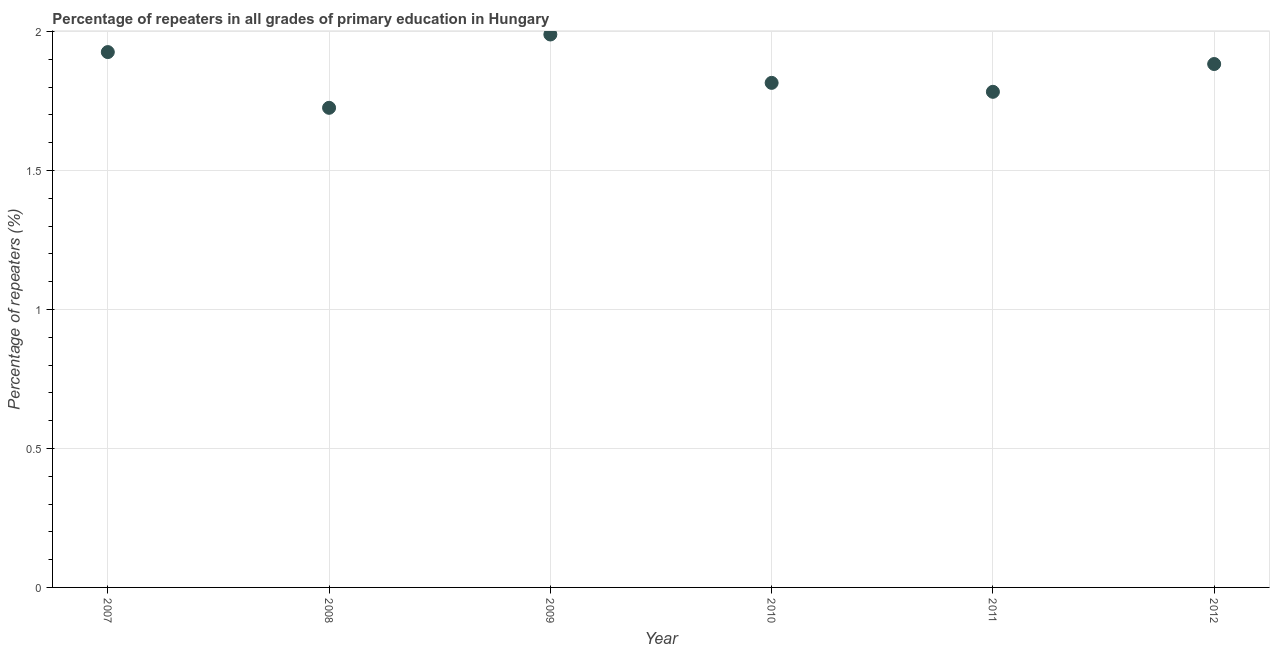What is the percentage of repeaters in primary education in 2010?
Keep it short and to the point. 1.82. Across all years, what is the maximum percentage of repeaters in primary education?
Give a very brief answer. 1.99. Across all years, what is the minimum percentage of repeaters in primary education?
Your response must be concise. 1.73. In which year was the percentage of repeaters in primary education maximum?
Keep it short and to the point. 2009. What is the sum of the percentage of repeaters in primary education?
Your response must be concise. 11.12. What is the difference between the percentage of repeaters in primary education in 2010 and 2011?
Provide a succinct answer. 0.03. What is the average percentage of repeaters in primary education per year?
Give a very brief answer. 1.85. What is the median percentage of repeaters in primary education?
Provide a short and direct response. 1.85. In how many years, is the percentage of repeaters in primary education greater than 1.8 %?
Make the answer very short. 4. What is the ratio of the percentage of repeaters in primary education in 2010 to that in 2011?
Your answer should be very brief. 1.02. Is the difference between the percentage of repeaters in primary education in 2008 and 2012 greater than the difference between any two years?
Ensure brevity in your answer.  No. What is the difference between the highest and the second highest percentage of repeaters in primary education?
Keep it short and to the point. 0.06. Is the sum of the percentage of repeaters in primary education in 2008 and 2012 greater than the maximum percentage of repeaters in primary education across all years?
Provide a succinct answer. Yes. What is the difference between the highest and the lowest percentage of repeaters in primary education?
Make the answer very short. 0.26. In how many years, is the percentage of repeaters in primary education greater than the average percentage of repeaters in primary education taken over all years?
Provide a short and direct response. 3. How many dotlines are there?
Keep it short and to the point. 1. How many years are there in the graph?
Your response must be concise. 6. Are the values on the major ticks of Y-axis written in scientific E-notation?
Offer a very short reply. No. Does the graph contain grids?
Your answer should be compact. Yes. What is the title of the graph?
Offer a terse response. Percentage of repeaters in all grades of primary education in Hungary. What is the label or title of the X-axis?
Keep it short and to the point. Year. What is the label or title of the Y-axis?
Your answer should be very brief. Percentage of repeaters (%). What is the Percentage of repeaters (%) in 2007?
Make the answer very short. 1.93. What is the Percentage of repeaters (%) in 2008?
Offer a terse response. 1.73. What is the Percentage of repeaters (%) in 2009?
Give a very brief answer. 1.99. What is the Percentage of repeaters (%) in 2010?
Offer a terse response. 1.82. What is the Percentage of repeaters (%) in 2011?
Ensure brevity in your answer.  1.78. What is the Percentage of repeaters (%) in 2012?
Make the answer very short. 1.88. What is the difference between the Percentage of repeaters (%) in 2007 and 2008?
Provide a short and direct response. 0.2. What is the difference between the Percentage of repeaters (%) in 2007 and 2009?
Make the answer very short. -0.06. What is the difference between the Percentage of repeaters (%) in 2007 and 2010?
Ensure brevity in your answer.  0.11. What is the difference between the Percentage of repeaters (%) in 2007 and 2011?
Your answer should be very brief. 0.14. What is the difference between the Percentage of repeaters (%) in 2007 and 2012?
Make the answer very short. 0.04. What is the difference between the Percentage of repeaters (%) in 2008 and 2009?
Keep it short and to the point. -0.26. What is the difference between the Percentage of repeaters (%) in 2008 and 2010?
Provide a short and direct response. -0.09. What is the difference between the Percentage of repeaters (%) in 2008 and 2011?
Keep it short and to the point. -0.06. What is the difference between the Percentage of repeaters (%) in 2008 and 2012?
Keep it short and to the point. -0.16. What is the difference between the Percentage of repeaters (%) in 2009 and 2010?
Ensure brevity in your answer.  0.17. What is the difference between the Percentage of repeaters (%) in 2009 and 2011?
Provide a short and direct response. 0.21. What is the difference between the Percentage of repeaters (%) in 2009 and 2012?
Make the answer very short. 0.11. What is the difference between the Percentage of repeaters (%) in 2010 and 2011?
Offer a very short reply. 0.03. What is the difference between the Percentage of repeaters (%) in 2010 and 2012?
Provide a succinct answer. -0.07. What is the difference between the Percentage of repeaters (%) in 2011 and 2012?
Your answer should be compact. -0.1. What is the ratio of the Percentage of repeaters (%) in 2007 to that in 2008?
Keep it short and to the point. 1.12. What is the ratio of the Percentage of repeaters (%) in 2007 to that in 2010?
Offer a very short reply. 1.06. What is the ratio of the Percentage of repeaters (%) in 2008 to that in 2009?
Give a very brief answer. 0.87. What is the ratio of the Percentage of repeaters (%) in 2008 to that in 2010?
Offer a very short reply. 0.95. What is the ratio of the Percentage of repeaters (%) in 2008 to that in 2011?
Make the answer very short. 0.97. What is the ratio of the Percentage of repeaters (%) in 2008 to that in 2012?
Keep it short and to the point. 0.92. What is the ratio of the Percentage of repeaters (%) in 2009 to that in 2010?
Offer a terse response. 1.1. What is the ratio of the Percentage of repeaters (%) in 2009 to that in 2011?
Ensure brevity in your answer.  1.12. What is the ratio of the Percentage of repeaters (%) in 2009 to that in 2012?
Keep it short and to the point. 1.06. What is the ratio of the Percentage of repeaters (%) in 2010 to that in 2011?
Provide a succinct answer. 1.02. What is the ratio of the Percentage of repeaters (%) in 2010 to that in 2012?
Your response must be concise. 0.96. What is the ratio of the Percentage of repeaters (%) in 2011 to that in 2012?
Your answer should be very brief. 0.95. 